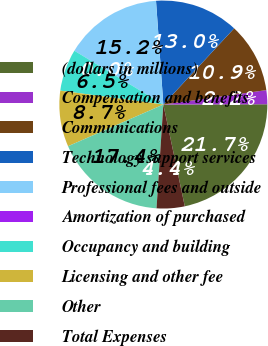<chart> <loc_0><loc_0><loc_500><loc_500><pie_chart><fcel>(dollars in millions)<fcel>Compensation and benefits<fcel>Communications<fcel>Technology support services<fcel>Professional fees and outside<fcel>Amortization of purchased<fcel>Occupancy and building<fcel>Licensing and other fee<fcel>Other<fcel>Total Expenses<nl><fcel>21.74%<fcel>2.17%<fcel>10.87%<fcel>13.04%<fcel>15.22%<fcel>0.0%<fcel>6.52%<fcel>8.7%<fcel>17.39%<fcel>4.35%<nl></chart> 